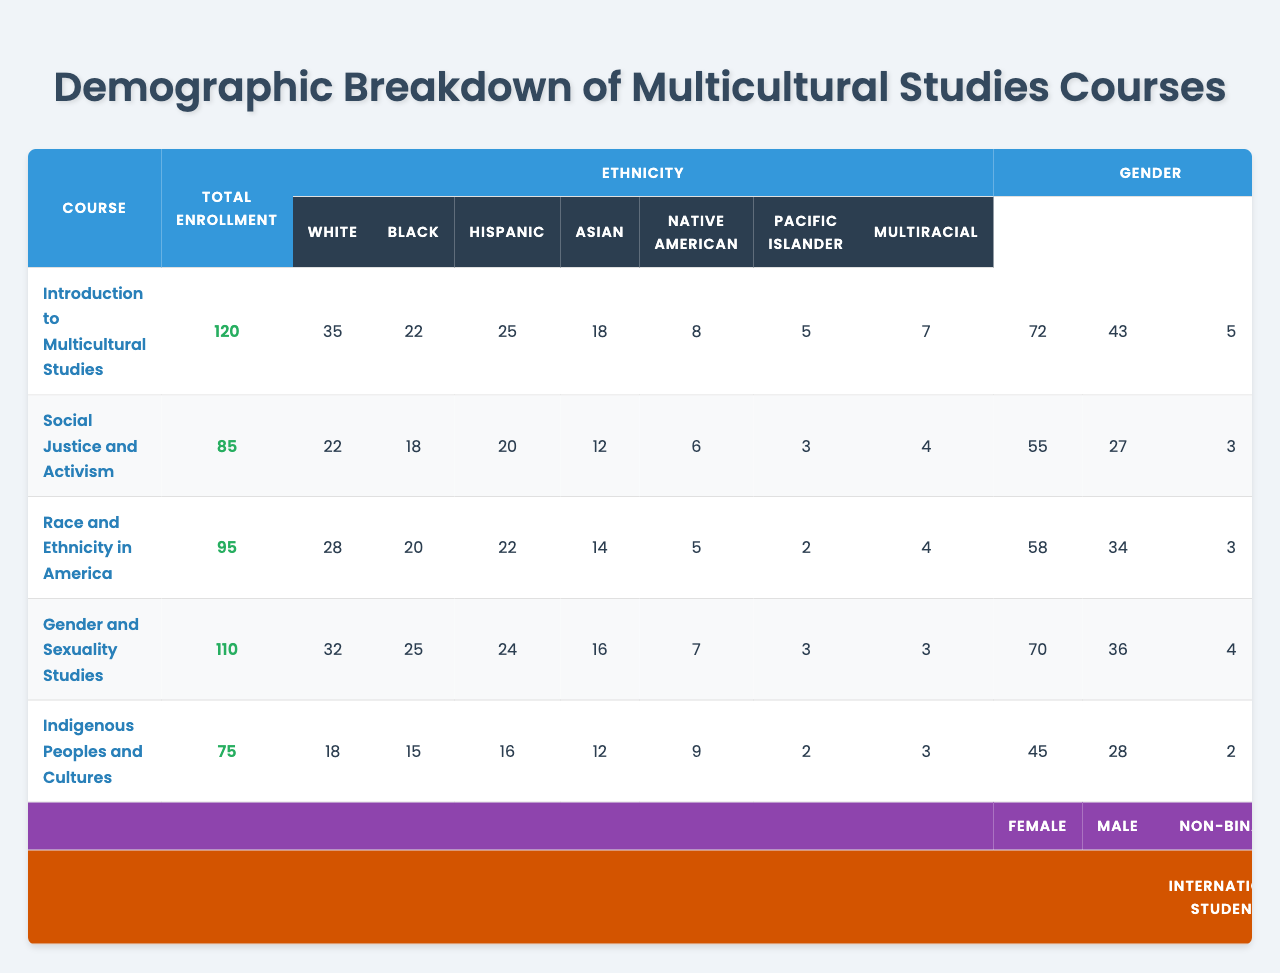What is the total enrollment in the course "Gender and Sexuality Studies"? Looking at the "Total Enrollment" column for "Gender and Sexuality Studies," the value is 110.
Answer: 110 How many Black students are enrolled in "Social Justice and Activism"? In the "Black" column corresponding to "Social Justice and Activism," the value is 18.
Answer: 18 Which course has the highest number of Asian students? By comparing the values in the "Asian" column, "Introduction to Multicultural Studies" has the highest value at 18.
Answer: Introduction to Multicultural Studies What is the total number of Female students across all courses? Summing the values in the "Female" column: 72 + 55 + 58 + 70 + 45 = 300.
Answer: 300 How many students are International Students in the course "Indigenous Peoples and Cultures"? The value in the "International Students" column for "Indigenous Peoples and Cultures" is 7.
Answer: 7 In which course is the number of First Generation Students the lowest, and what is that number? The values in the "First Generation Students" column are: 35, 28, 30, 32, 25. The lowest value is in "Indigenous Peoples and Cultures" with 25 students.
Answer: Indigenous Peoples and Cultures, 25 What percentage of the total enrollment in "Race and Ethnicity in America" are Multiracial students? There are 95 total students, with 4 being Multiracial. The percentage is (4/95) * 100 ≈ 4.21%.
Answer: 4.21% How many more Female students are there compared to Male students in "Introduction to Multicultural Studies"? In "Introduction to Multicultural Studies," there are 72 Female students and 43 Male students. The difference is 72 - 43 = 29.
Answer: 29 Which ethnicity has the highest enrollment in "Hispanic" students across all courses? The values in the "Hispanic" column show 25, 20, 22, 24, and 16, with 25 being the highest in "Introduction to Multicultural Studies."
Answer: Introduction to Multicultural Studies What is the median number of Total Enrollment across all courses? Listing the Total Enrollment values: 120, 85, 95, 110, 75. Arranging them: 75, 85, 95, 110, 120, the median (middle value) is 95.
Answer: 95 In the course with the highest enrollment, what proportion of students are Female? The course with the highest total enrollment is "Introduction to Multicultural Studies" with 72 Female students out of 120 total, giving a proportion of 72/120 = 0.6 or 60%.
Answer: 60% 